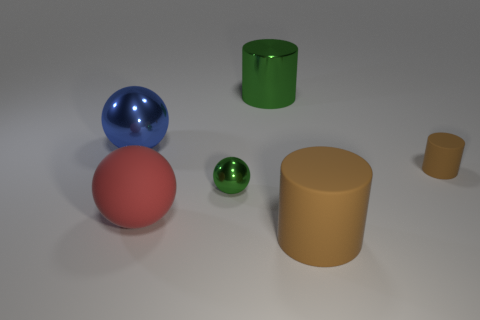What material do the objects in the image seem to be made of, based on their appearance? The objects in the image may be made of different materials. The large brown cylinder and the smaller golden one appear to be made of a matte material like rubber due to their non-reflective surface. The blue and the small green spheres, as well as the green cylinder, have reflective surfaces suggesting they could be made of a glossy material like plastic or polished metal. 